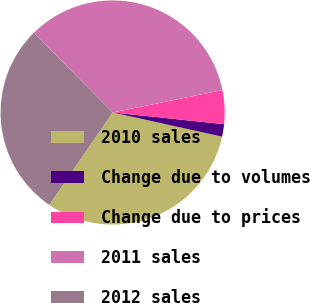Convert chart. <chart><loc_0><loc_0><loc_500><loc_500><pie_chart><fcel>2010 sales<fcel>Change due to volumes<fcel>Change due to prices<fcel>2011 sales<fcel>2012 sales<nl><fcel>31.11%<fcel>1.79%<fcel>4.87%<fcel>34.19%<fcel>28.03%<nl></chart> 